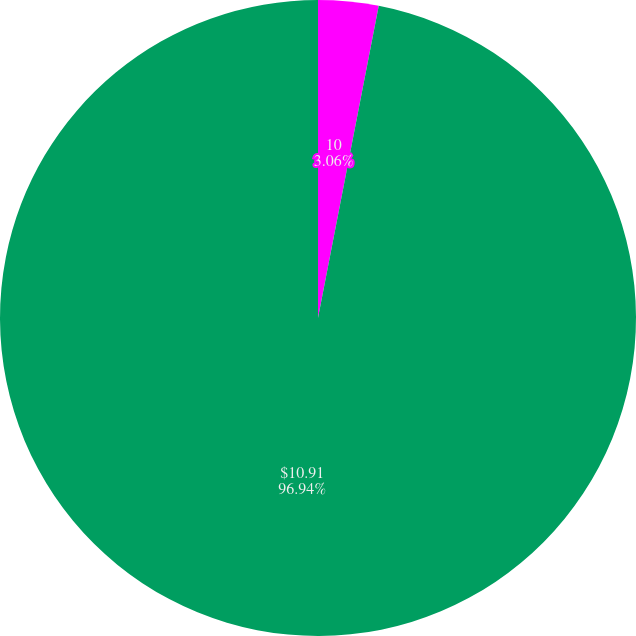Convert chart to OTSL. <chart><loc_0><loc_0><loc_500><loc_500><pie_chart><fcel>0.5%<fcel>10<fcel>14,000<fcel>$10.91<nl><fcel>0.0%<fcel>3.06%<fcel>0.0%<fcel>96.94%<nl></chart> 